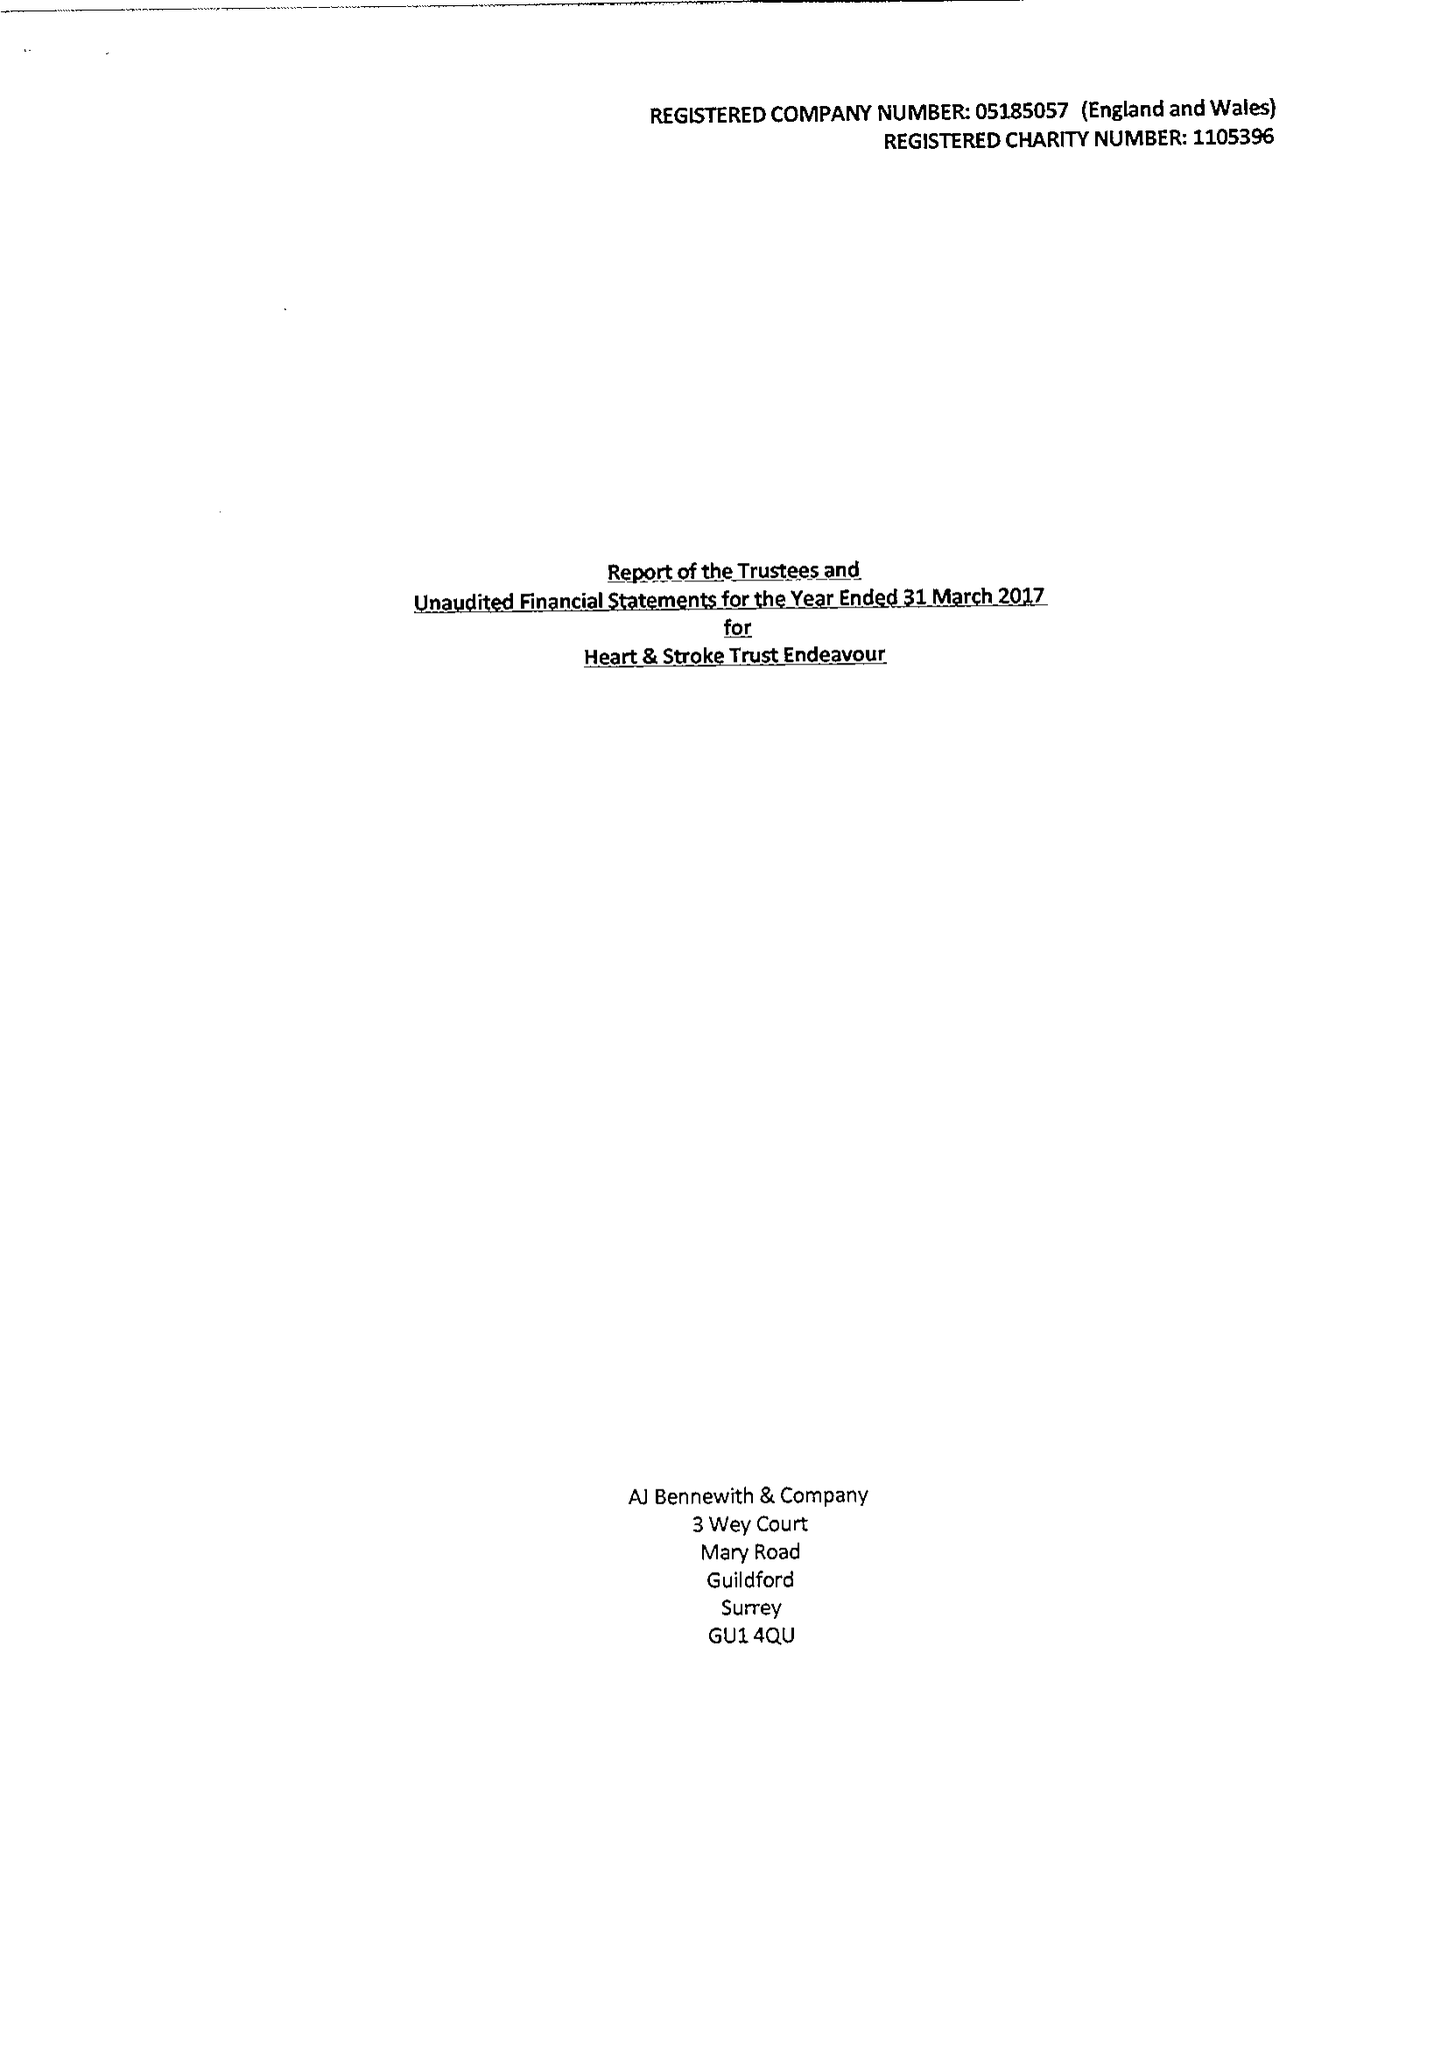What is the value for the address__street_line?
Answer the question using a single word or phrase. 4 FREDERICK SANGER ROAD 